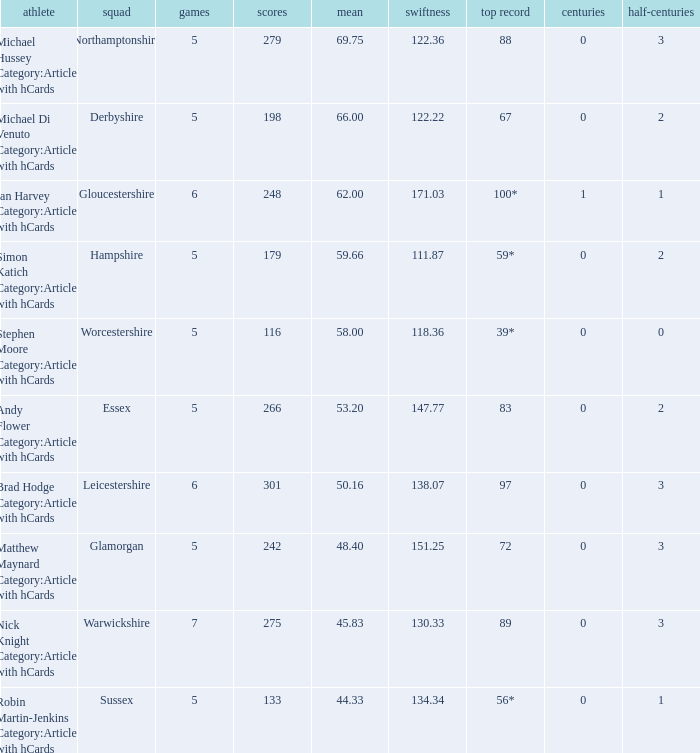Write the full table. {'header': ['athlete', 'squad', 'games', 'scores', 'mean', 'swiftness', 'top record', 'centuries', 'half-centuries'], 'rows': [['Michael Hussey Category:Articles with hCards', 'Northamptonshire', '5', '279', '69.75', '122.36', '88', '0', '3'], ['Michael Di Venuto Category:Articles with hCards', 'Derbyshire', '5', '198', '66.00', '122.22', '67', '0', '2'], ['Ian Harvey Category:Articles with hCards', 'Gloucestershire', '6', '248', '62.00', '171.03', '100*', '1', '1'], ['Simon Katich Category:Articles with hCards', 'Hampshire', '5', '179', '59.66', '111.87', '59*', '0', '2'], ['Stephen Moore Category:Articles with hCards', 'Worcestershire', '5', '116', '58.00', '118.36', '39*', '0', '0'], ['Andy Flower Category:Articles with hCards', 'Essex', '5', '266', '53.20', '147.77', '83', '0', '2'], ['Brad Hodge Category:Articles with hCards', 'Leicestershire', '6', '301', '50.16', '138.07', '97', '0', '3'], ['Matthew Maynard Category:Articles with hCards', 'Glamorgan', '5', '242', '48.40', '151.25', '72', '0', '3'], ['Nick Knight Category:Articles with hCards', 'Warwickshire', '7', '275', '45.83', '130.33', '89', '0', '3'], ['Robin Martin-Jenkins Category:Articles with hCards', 'Sussex', '5', '133', '44.33', '134.34', '56*', '0', '1']]} What is the least quantity of matches? 5.0. 